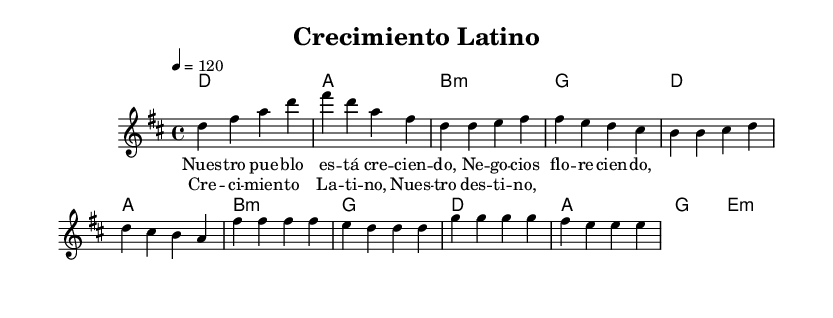What is the key signature of this music? The key signature shown is D major, which is indicated by two sharps (F# and C#) at the beginning of the sheet music.
Answer: D major What is the time signature of this music? The time signature is 4/4, which is represented at the beginning and denotes that there are four beats in each measure and a quarter note gets one beat.
Answer: 4/4 What is the tempo marking for this piece? The tempo marking of the piece is 120 beats per minute, which is indicated by the tempo directive (4 = 120) below the global section.
Answer: 120 How many measures are there in the chorus? The chorus consists of four measures, as counted from the musical notation presented.
Answer: 4 What is the first note of the melody? The first note of the melody in the piece is D, which can be found at the start of the melody section.
Answer: D What style of fusion does this music represent? The music represents Latin-influenced pop fusion, which is characterized by its upbeat tempo and incorporation of Latin rhythms and melodies.
Answer: Latin-influenced pop fusion What is the theme conveyed in the lyrics of the verse? The theme conveyed in the verse is local business growth, as described in the lyrics which discuss flourishing businesses in the community.
Answer: Local business growth 